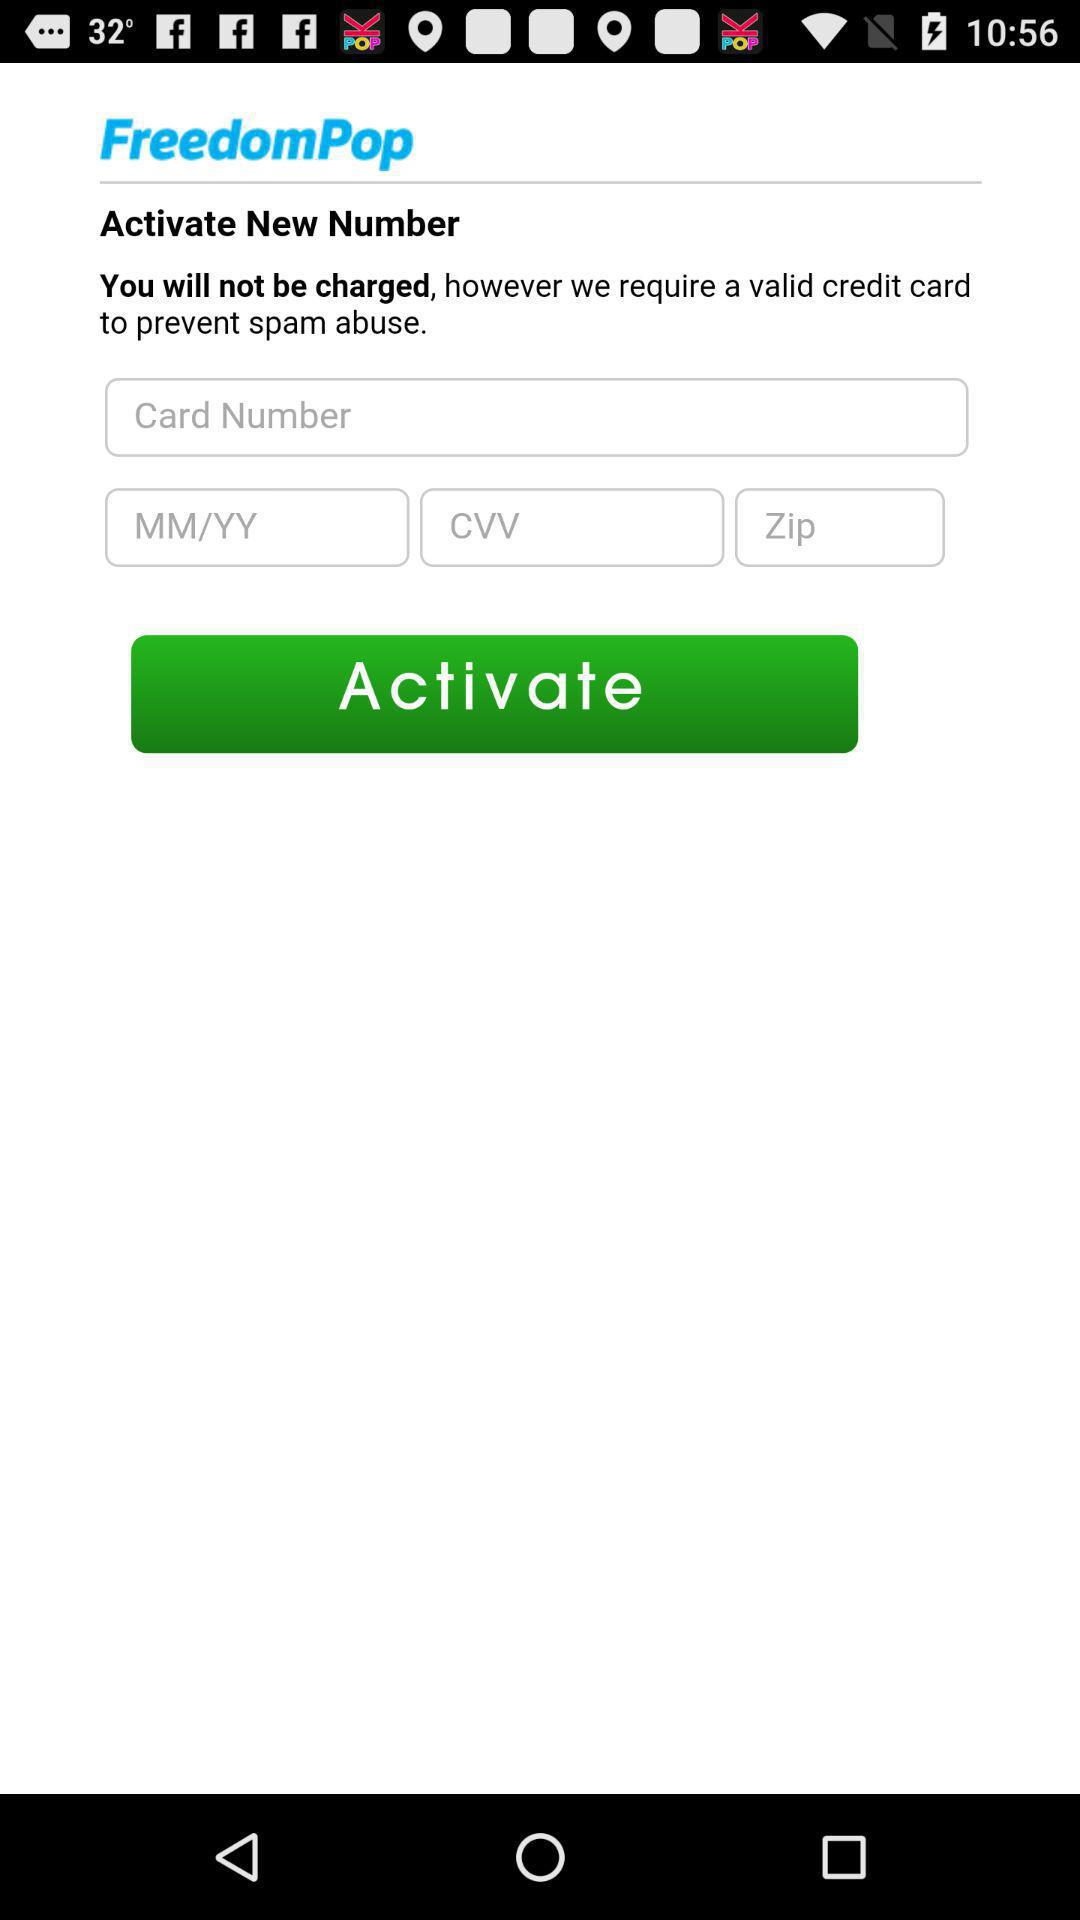How many text inputs are on the screen?
Answer the question using a single word or phrase. 4 